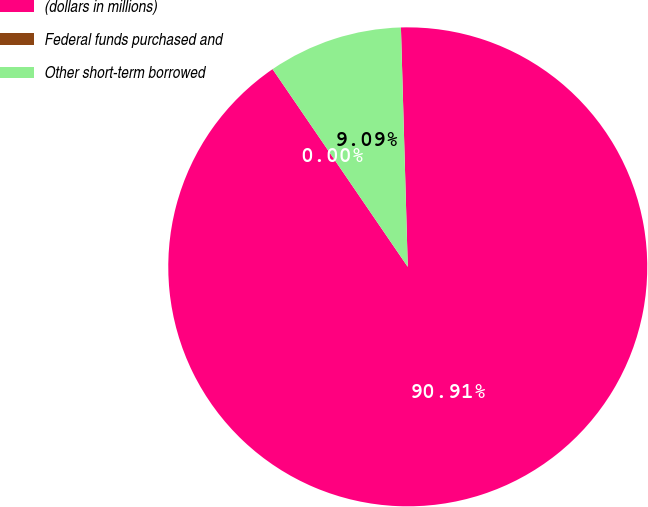<chart> <loc_0><loc_0><loc_500><loc_500><pie_chart><fcel>(dollars in millions)<fcel>Federal funds purchased and<fcel>Other short-term borrowed<nl><fcel>90.9%<fcel>0.0%<fcel>9.09%<nl></chart> 